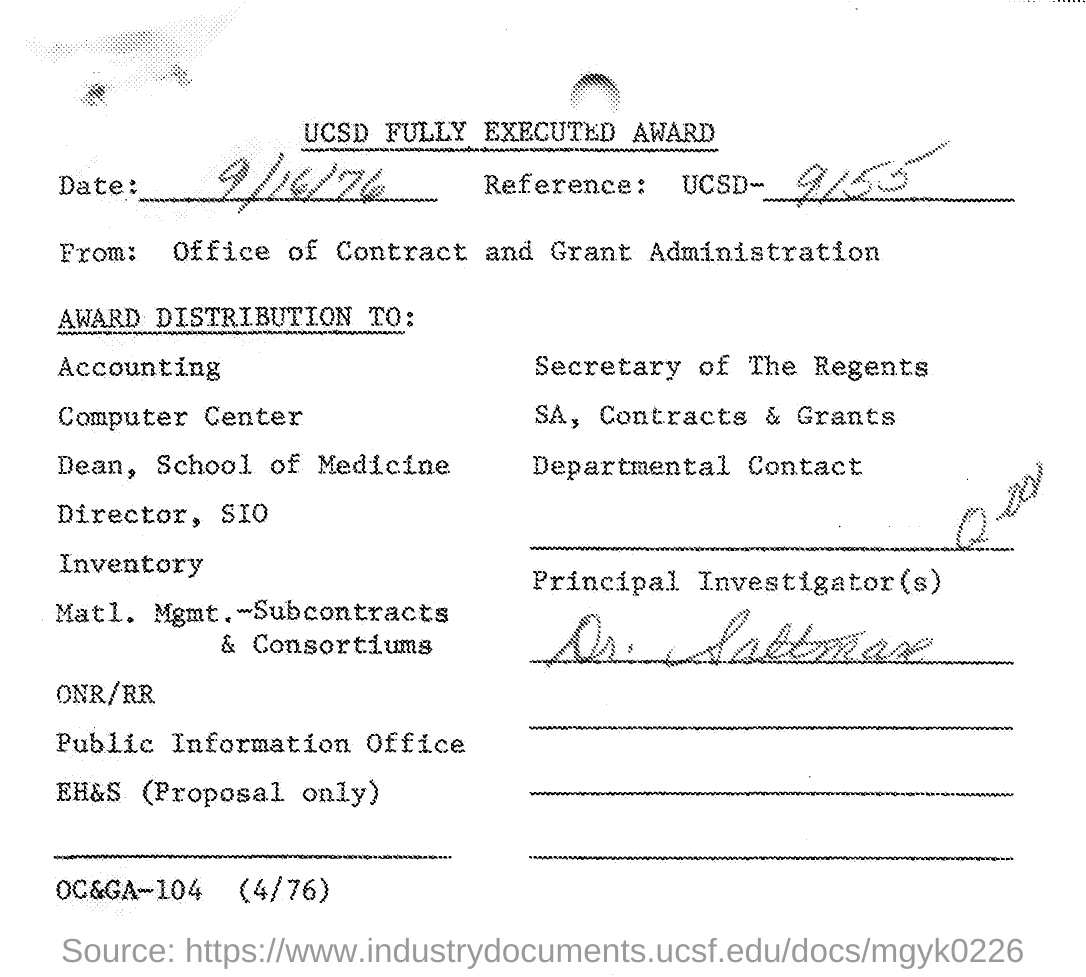Highlight a few significant elements in this photo. The reference UCSD number mentioned in the given letter is 9155.. The principal investigator mentioned in the given letter is Dr. Saltman. 